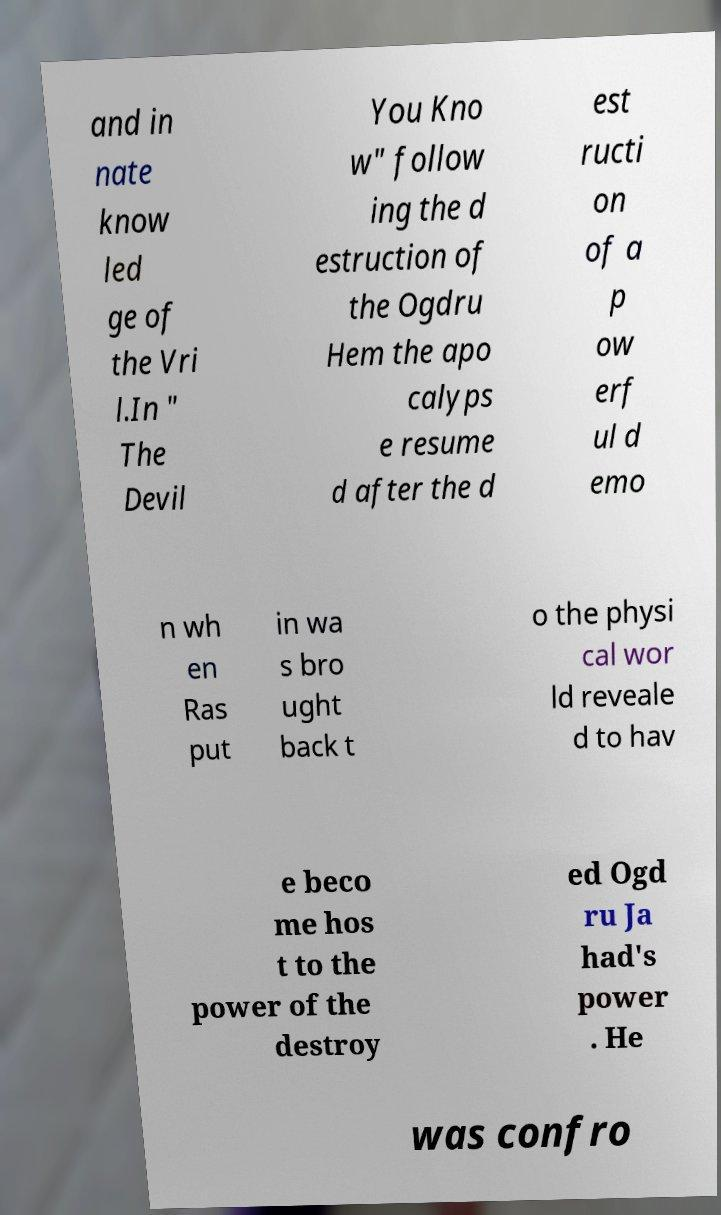Could you extract and type out the text from this image? and in nate know led ge of the Vri l.In " The Devil You Kno w" follow ing the d estruction of the Ogdru Hem the apo calyps e resume d after the d est ructi on of a p ow erf ul d emo n wh en Ras put in wa s bro ught back t o the physi cal wor ld reveale d to hav e beco me hos t to the power of the destroy ed Ogd ru Ja had's power . He was confro 